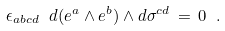Convert formula to latex. <formula><loc_0><loc_0><loc_500><loc_500>\epsilon _ { a b c d } \ d ( e ^ { a } \wedge e ^ { b } ) \wedge d \sigma ^ { c d } \, = \, 0 \ .</formula> 